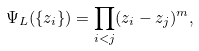Convert formula to latex. <formula><loc_0><loc_0><loc_500><loc_500>\Psi _ { L } ( \{ z _ { i } \} ) = \prod _ { i < j } ( z _ { i } - z _ { j } ) ^ { m } ,</formula> 